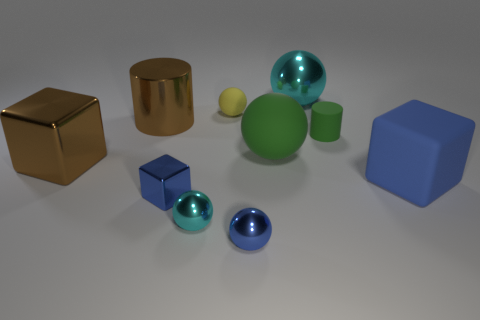Is there any other thing that has the same color as the shiny cylinder?
Your answer should be compact. Yes. Does the big matte ball have the same color as the matte cylinder?
Give a very brief answer. Yes. What color is the cube that is the same material as the green ball?
Offer a very short reply. Blue. Is the material of the large sphere behind the brown shiny cylinder the same as the cyan ball that is in front of the big green rubber ball?
Provide a succinct answer. Yes. The sphere that is the same color as the small cylinder is what size?
Provide a short and direct response. Large. What material is the big thing right of the large cyan shiny sphere?
Your answer should be very brief. Rubber. Do the tiny cyan thing that is behind the blue sphere and the matte thing on the left side of the large green matte object have the same shape?
Keep it short and to the point. Yes. What is the material of the big ball that is the same color as the tiny cylinder?
Your answer should be compact. Rubber. Are any brown rubber things visible?
Provide a short and direct response. No. What material is the green thing that is the same shape as the tiny cyan metal object?
Make the answer very short. Rubber. 